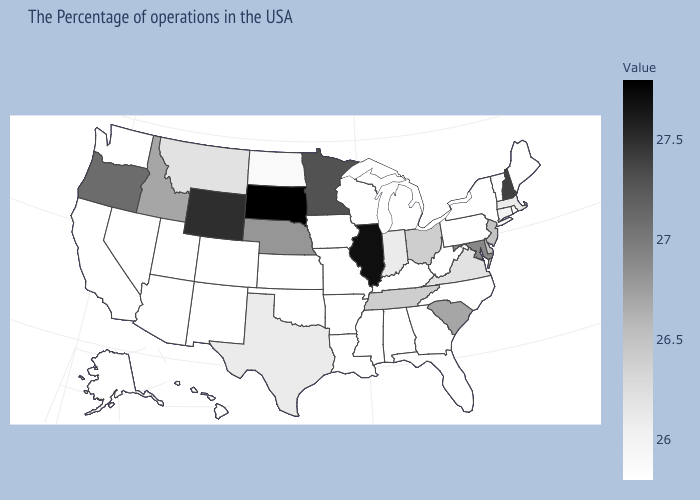Does Maryland have a higher value than Oregon?
Be succinct. No. Does Maryland have the highest value in the South?
Keep it brief. Yes. Does South Dakota have the highest value in the USA?
Write a very short answer. Yes. Does Alaska have a lower value than New Jersey?
Short answer required. Yes. Among the states that border Minnesota , which have the lowest value?
Give a very brief answer. Wisconsin, Iowa. Does Oregon have a lower value than Arizona?
Give a very brief answer. No. 